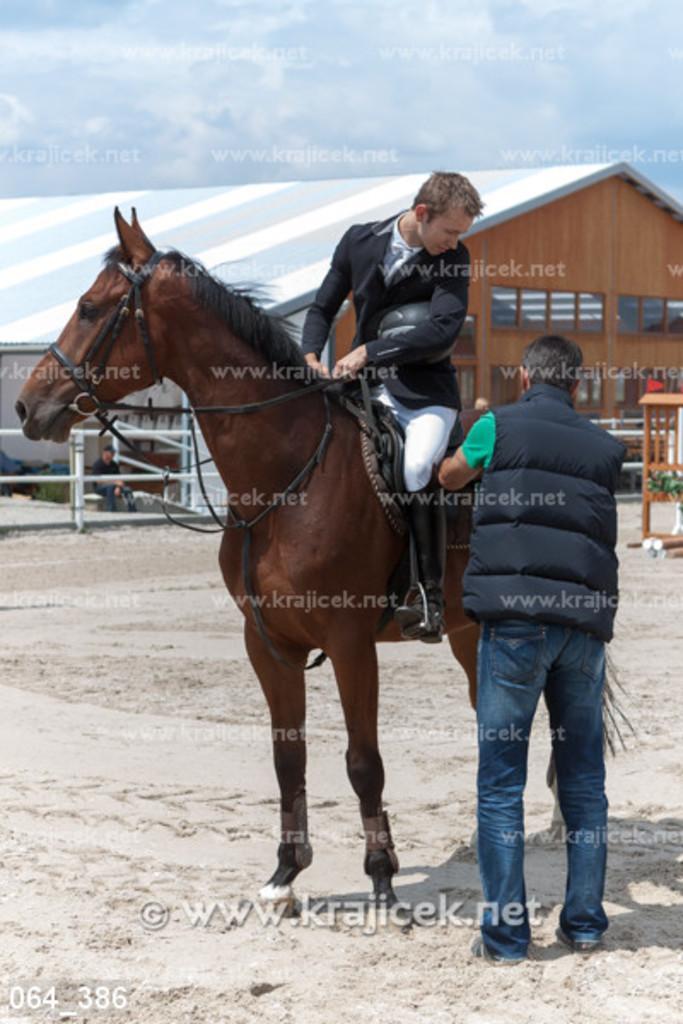In one or two sentences, can you explain what this image depicts? There is a person in black color jacket, holding helmet with one hand, holding threads with both hands and sitting on the horse, which is on the ground, near a person who is standing on the ground. In the background, there is a shed, there are clouds in the blue sky. 